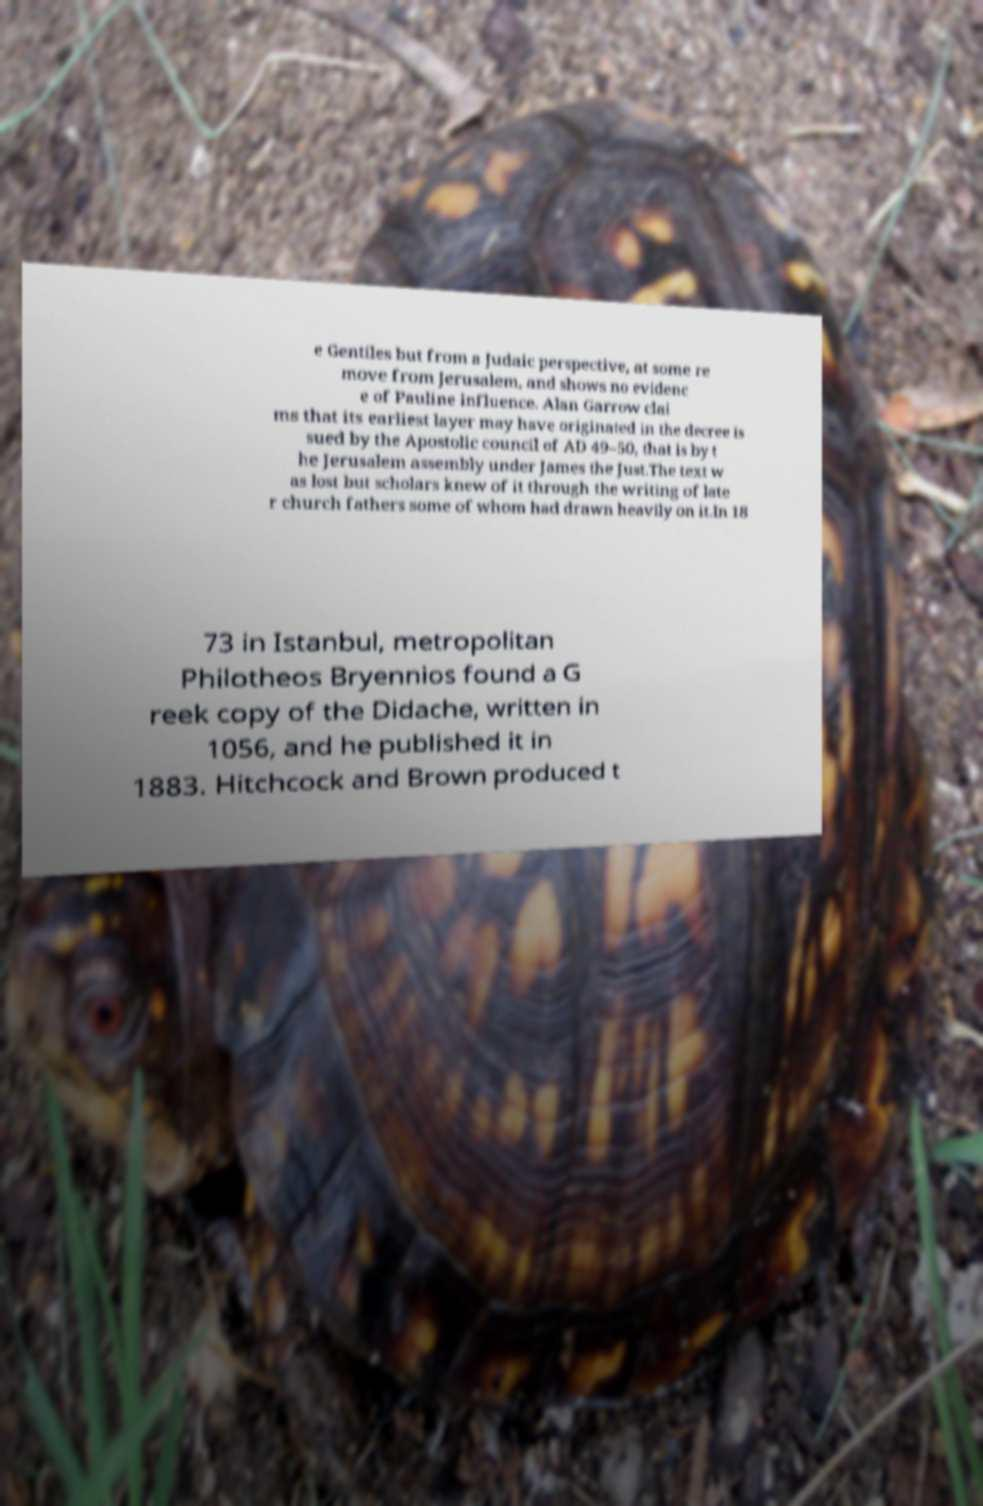For documentation purposes, I need the text within this image transcribed. Could you provide that? e Gentiles but from a Judaic perspective, at some re move from Jerusalem, and shows no evidenc e of Pauline influence. Alan Garrow clai ms that its earliest layer may have originated in the decree is sued by the Apostolic council of AD 49–50, that is by t he Jerusalem assembly under James the Just.The text w as lost but scholars knew of it through the writing of late r church fathers some of whom had drawn heavily on it.In 18 73 in Istanbul, metropolitan Philotheos Bryennios found a G reek copy of the Didache, written in 1056, and he published it in 1883. Hitchcock and Brown produced t 